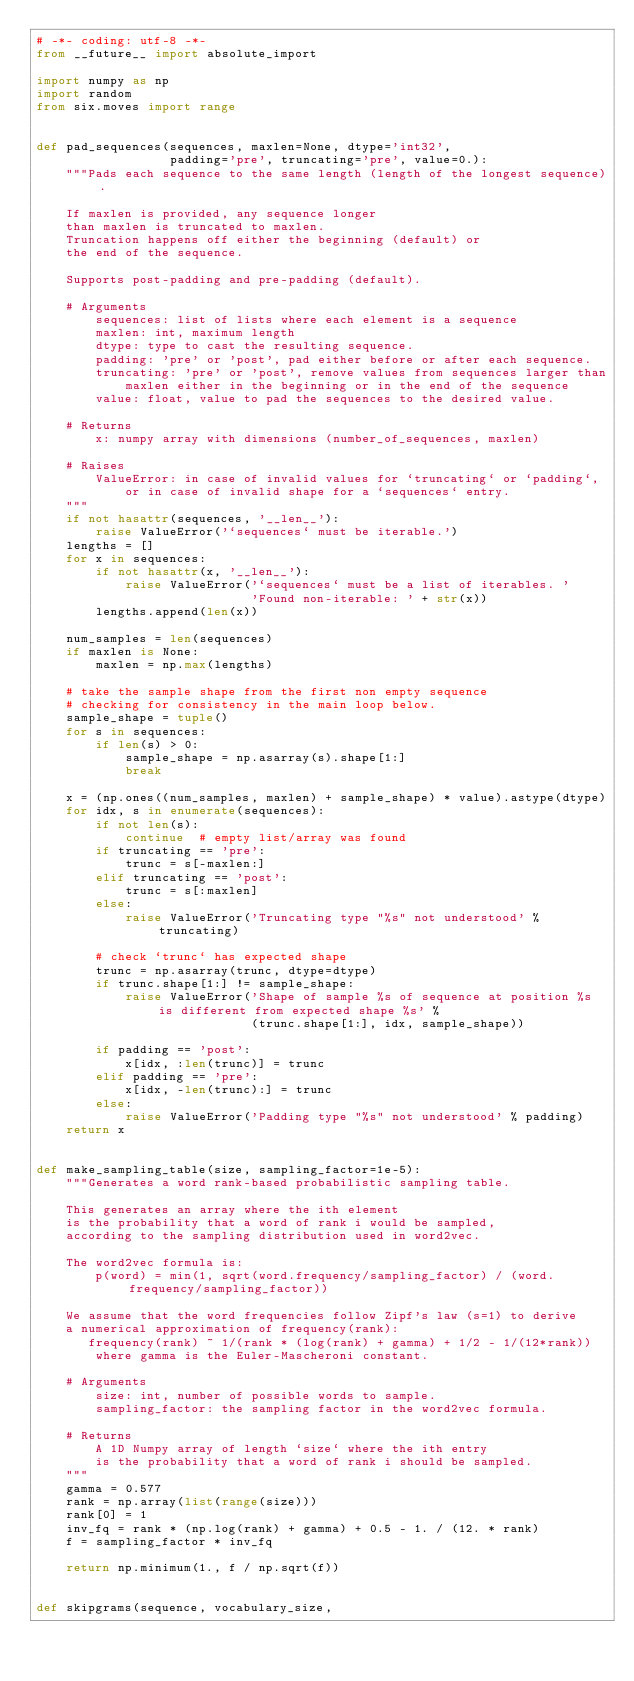<code> <loc_0><loc_0><loc_500><loc_500><_Python_># -*- coding: utf-8 -*-
from __future__ import absolute_import

import numpy as np
import random
from six.moves import range


def pad_sequences(sequences, maxlen=None, dtype='int32',
                  padding='pre', truncating='pre', value=0.):
    """Pads each sequence to the same length (length of the longest sequence).

    If maxlen is provided, any sequence longer
    than maxlen is truncated to maxlen.
    Truncation happens off either the beginning (default) or
    the end of the sequence.

    Supports post-padding and pre-padding (default).

    # Arguments
        sequences: list of lists where each element is a sequence
        maxlen: int, maximum length
        dtype: type to cast the resulting sequence.
        padding: 'pre' or 'post', pad either before or after each sequence.
        truncating: 'pre' or 'post', remove values from sequences larger than
            maxlen either in the beginning or in the end of the sequence
        value: float, value to pad the sequences to the desired value.

    # Returns
        x: numpy array with dimensions (number_of_sequences, maxlen)

    # Raises
        ValueError: in case of invalid values for `truncating` or `padding`,
            or in case of invalid shape for a `sequences` entry.
    """
    if not hasattr(sequences, '__len__'):
        raise ValueError('`sequences` must be iterable.')
    lengths = []
    for x in sequences:
        if not hasattr(x, '__len__'):
            raise ValueError('`sequences` must be a list of iterables. '
                             'Found non-iterable: ' + str(x))
        lengths.append(len(x))

    num_samples = len(sequences)
    if maxlen is None:
        maxlen = np.max(lengths)

    # take the sample shape from the first non empty sequence
    # checking for consistency in the main loop below.
    sample_shape = tuple()
    for s in sequences:
        if len(s) > 0:
            sample_shape = np.asarray(s).shape[1:]
            break

    x = (np.ones((num_samples, maxlen) + sample_shape) * value).astype(dtype)
    for idx, s in enumerate(sequences):
        if not len(s):
            continue  # empty list/array was found
        if truncating == 'pre':
            trunc = s[-maxlen:]
        elif truncating == 'post':
            trunc = s[:maxlen]
        else:
            raise ValueError('Truncating type "%s" not understood' % truncating)

        # check `trunc` has expected shape
        trunc = np.asarray(trunc, dtype=dtype)
        if trunc.shape[1:] != sample_shape:
            raise ValueError('Shape of sample %s of sequence at position %s is different from expected shape %s' %
                             (trunc.shape[1:], idx, sample_shape))

        if padding == 'post':
            x[idx, :len(trunc)] = trunc
        elif padding == 'pre':
            x[idx, -len(trunc):] = trunc
        else:
            raise ValueError('Padding type "%s" not understood' % padding)
    return x


def make_sampling_table(size, sampling_factor=1e-5):
    """Generates a word rank-based probabilistic sampling table.

    This generates an array where the ith element
    is the probability that a word of rank i would be sampled,
    according to the sampling distribution used in word2vec.

    The word2vec formula is:
        p(word) = min(1, sqrt(word.frequency/sampling_factor) / (word.frequency/sampling_factor))

    We assume that the word frequencies follow Zipf's law (s=1) to derive
    a numerical approximation of frequency(rank):
       frequency(rank) ~ 1/(rank * (log(rank) + gamma) + 1/2 - 1/(12*rank))
        where gamma is the Euler-Mascheroni constant.

    # Arguments
        size: int, number of possible words to sample.
        sampling_factor: the sampling factor in the word2vec formula.

    # Returns
        A 1D Numpy array of length `size` where the ith entry
        is the probability that a word of rank i should be sampled.
    """
    gamma = 0.577
    rank = np.array(list(range(size)))
    rank[0] = 1
    inv_fq = rank * (np.log(rank) + gamma) + 0.5 - 1. / (12. * rank)
    f = sampling_factor * inv_fq

    return np.minimum(1., f / np.sqrt(f))


def skipgrams(sequence, vocabulary_size,</code> 